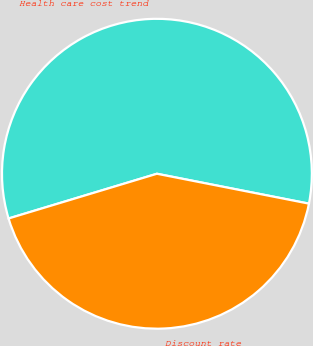<chart> <loc_0><loc_0><loc_500><loc_500><pie_chart><fcel>Health care cost trend<fcel>Discount rate<nl><fcel>57.75%<fcel>42.25%<nl></chart> 